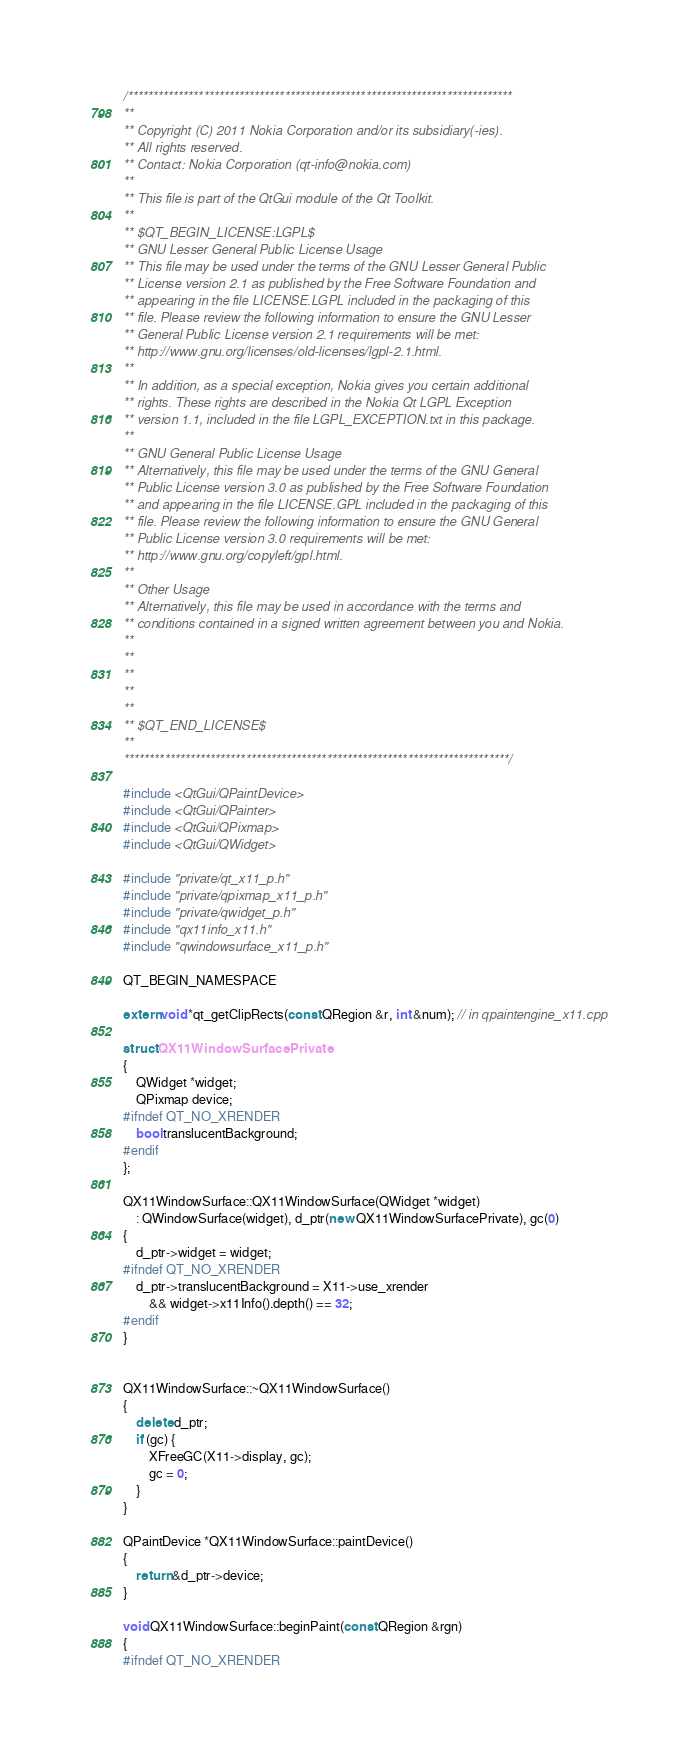Convert code to text. <code><loc_0><loc_0><loc_500><loc_500><_C++_>/****************************************************************************
**
** Copyright (C) 2011 Nokia Corporation and/or its subsidiary(-ies).
** All rights reserved.
** Contact: Nokia Corporation (qt-info@nokia.com)
**
** This file is part of the QtGui module of the Qt Toolkit.
**
** $QT_BEGIN_LICENSE:LGPL$
** GNU Lesser General Public License Usage
** This file may be used under the terms of the GNU Lesser General Public
** License version 2.1 as published by the Free Software Foundation and
** appearing in the file LICENSE.LGPL included in the packaging of this
** file. Please review the following information to ensure the GNU Lesser
** General Public License version 2.1 requirements will be met:
** http://www.gnu.org/licenses/old-licenses/lgpl-2.1.html.
**
** In addition, as a special exception, Nokia gives you certain additional
** rights. These rights are described in the Nokia Qt LGPL Exception
** version 1.1, included in the file LGPL_EXCEPTION.txt in this package.
**
** GNU General Public License Usage
** Alternatively, this file may be used under the terms of the GNU General
** Public License version 3.0 as published by the Free Software Foundation
** and appearing in the file LICENSE.GPL included in the packaging of this
** file. Please review the following information to ensure the GNU General
** Public License version 3.0 requirements will be met:
** http://www.gnu.org/copyleft/gpl.html.
**
** Other Usage
** Alternatively, this file may be used in accordance with the terms and
** conditions contained in a signed written agreement between you and Nokia.
**
**
**
**
**
** $QT_END_LICENSE$
**
****************************************************************************/

#include <QtGui/QPaintDevice>
#include <QtGui/QPainter>
#include <QtGui/QPixmap>
#include <QtGui/QWidget>

#include "private/qt_x11_p.h"
#include "private/qpixmap_x11_p.h"
#include "private/qwidget_p.h"
#include "qx11info_x11.h"
#include "qwindowsurface_x11_p.h"

QT_BEGIN_NAMESPACE

extern void *qt_getClipRects(const QRegion &r, int &num); // in qpaintengine_x11.cpp

struct QX11WindowSurfacePrivate
{
    QWidget *widget;
    QPixmap device;
#ifndef QT_NO_XRENDER
    bool translucentBackground;
#endif
};

QX11WindowSurface::QX11WindowSurface(QWidget *widget)
    : QWindowSurface(widget), d_ptr(new QX11WindowSurfacePrivate), gc(0)
{
    d_ptr->widget = widget;
#ifndef QT_NO_XRENDER
    d_ptr->translucentBackground = X11->use_xrender
        && widget->x11Info().depth() == 32;
#endif
}


QX11WindowSurface::~QX11WindowSurface()
{
    delete d_ptr;
    if (gc) {
        XFreeGC(X11->display, gc);
        gc = 0;
    }
}

QPaintDevice *QX11WindowSurface::paintDevice()
{
    return &d_ptr->device;
}

void QX11WindowSurface::beginPaint(const QRegion &rgn)
{
#ifndef QT_NO_XRENDER</code> 